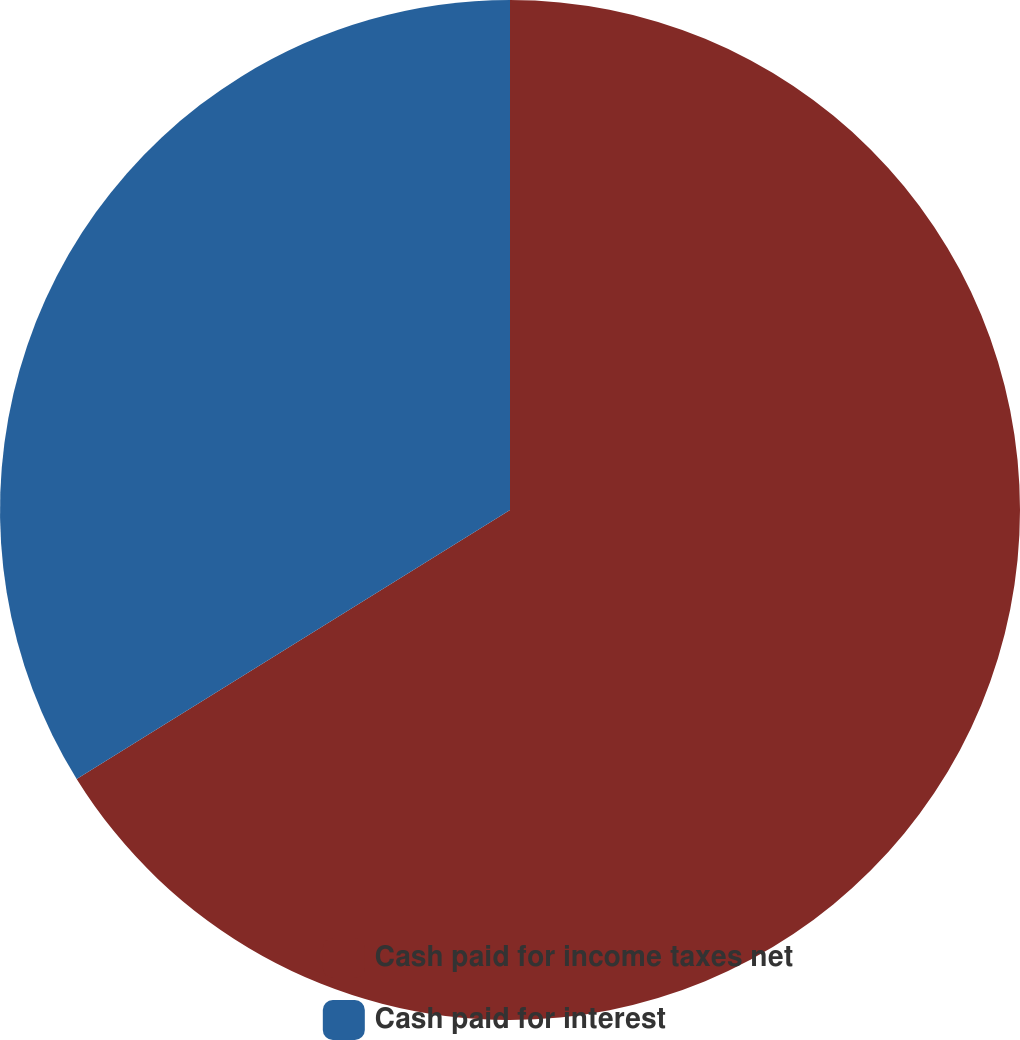<chart> <loc_0><loc_0><loc_500><loc_500><pie_chart><fcel>Cash paid for income taxes net<fcel>Cash paid for interest<nl><fcel>66.16%<fcel>33.84%<nl></chart> 